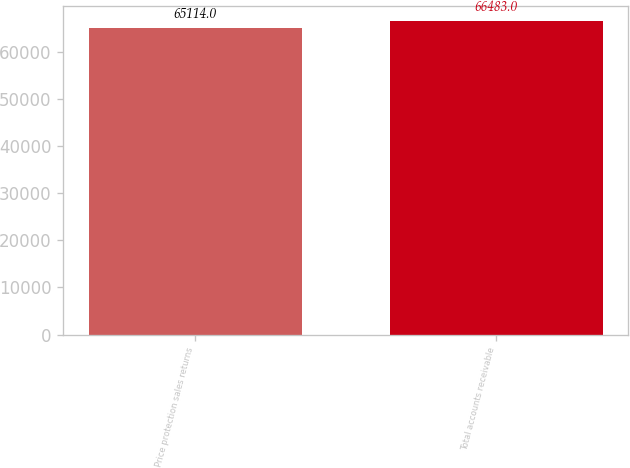Convert chart. <chart><loc_0><loc_0><loc_500><loc_500><bar_chart><fcel>Price protection sales returns<fcel>Total accounts receivable<nl><fcel>65114<fcel>66483<nl></chart> 